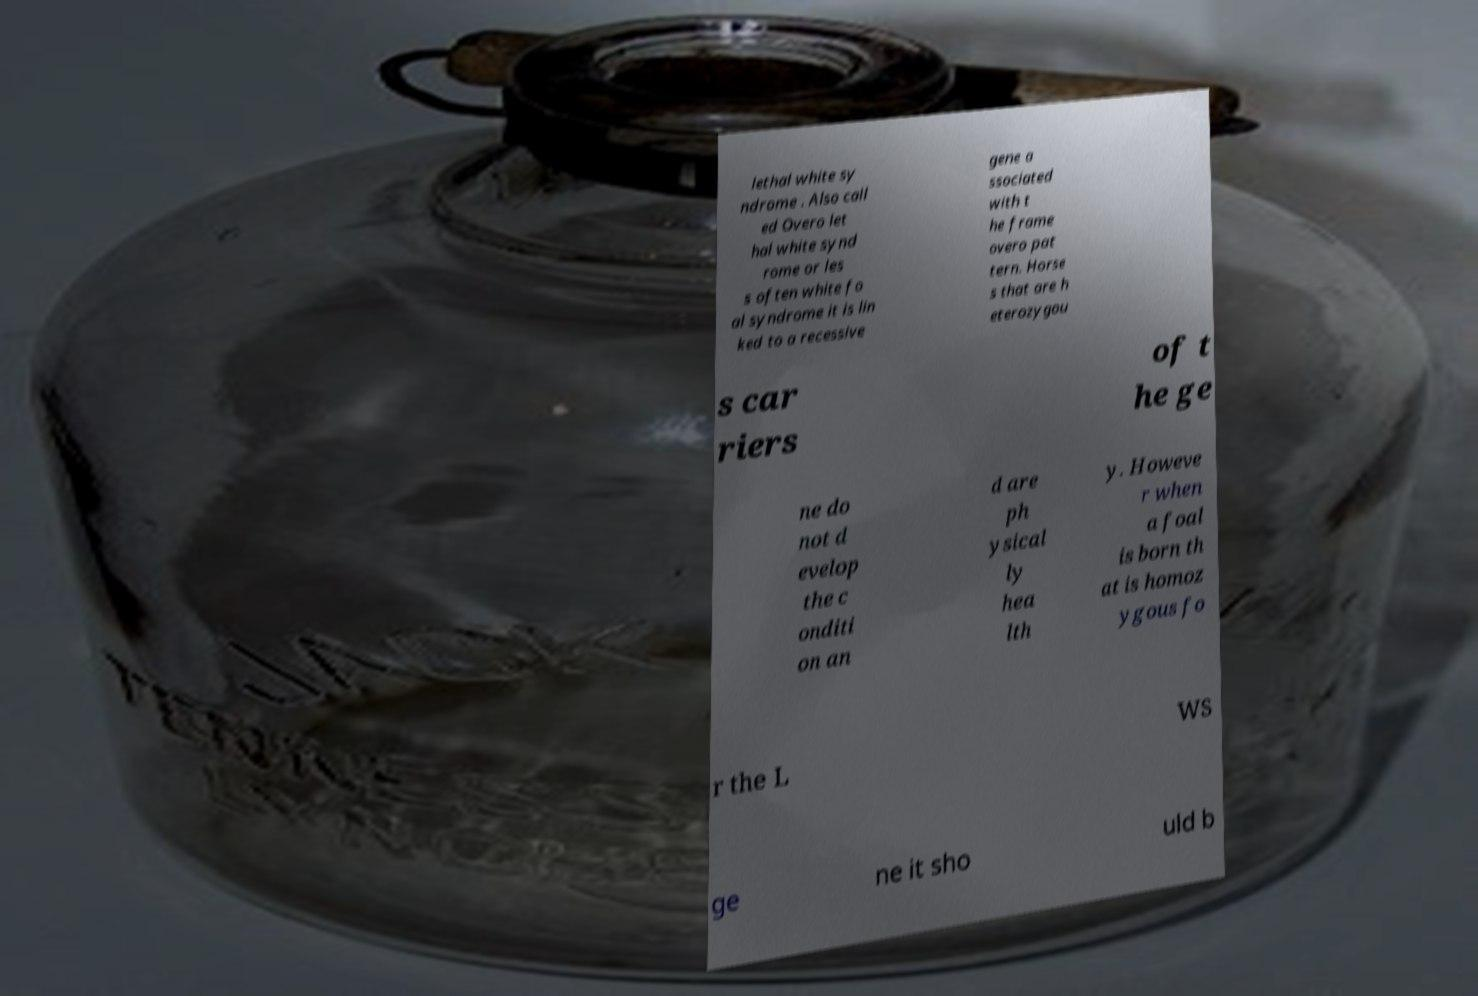Can you accurately transcribe the text from the provided image for me? lethal white sy ndrome . Also call ed Overo let hal white synd rome or les s often white fo al syndrome it is lin ked to a recessive gene a ssociated with t he frame overo pat tern. Horse s that are h eterozygou s car riers of t he ge ne do not d evelop the c onditi on an d are ph ysical ly hea lth y. Howeve r when a foal is born th at is homoz ygous fo r the L WS ge ne it sho uld b 